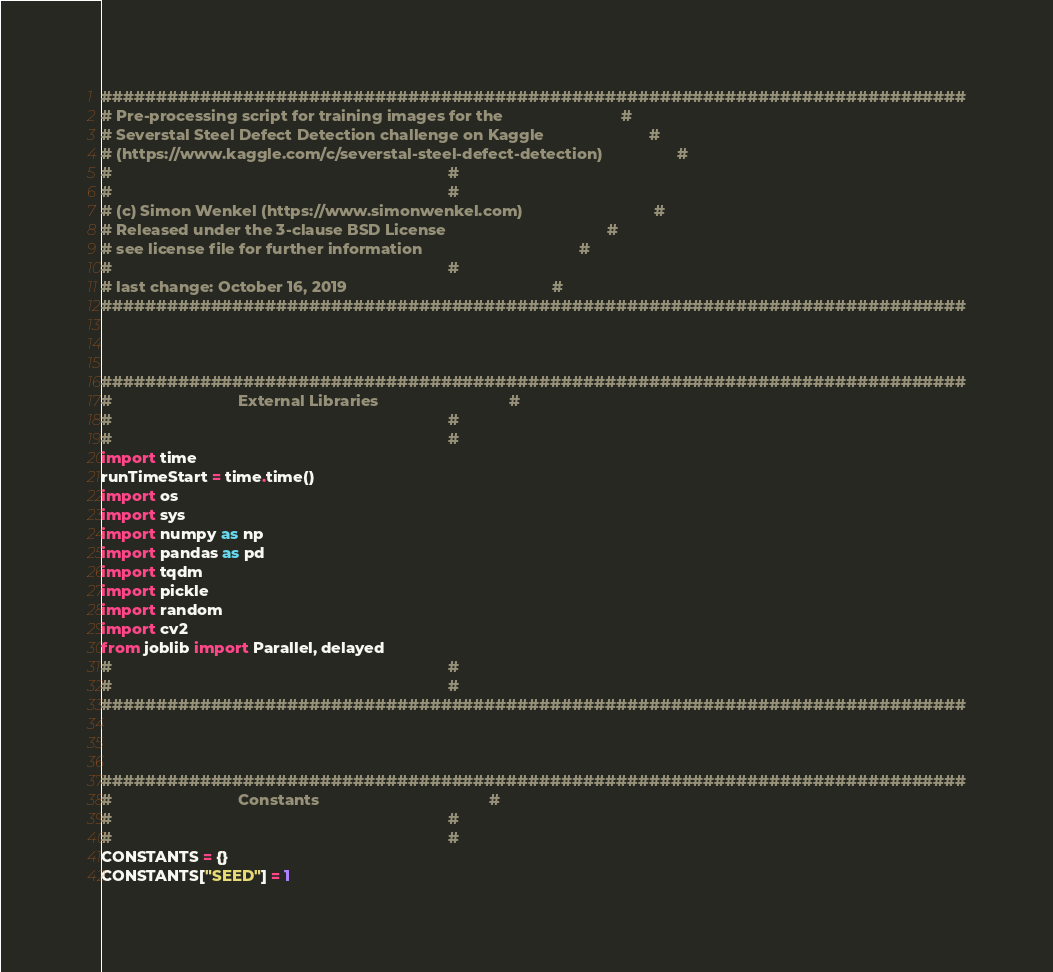Convert code to text. <code><loc_0><loc_0><loc_500><loc_500><_Python_>###############################################################################
# Pre-processing script for training images for the                           #
# Severstal Steel Defect Detection challenge on Kaggle                        #
# (https://www.kaggle.com/c/severstal-steel-defect-detection)                 #
#                                                                             #
#                                                                             #
# (c) Simon Wenkel (https://www.simonwenkel.com)                              #
# Released under the 3-clause BSD License                                     #
# see license file for further information                                    #
#                                                                             #
# last change: October 16, 2019                                               #
###############################################################################



###############################################################################
#                             External Libraries                              #
#                                                                             #
#                                                                             #
import time
runTimeStart = time.time()
import os
import sys
import numpy as np
import pandas as pd
import tqdm
import pickle
import random
import cv2
from joblib import Parallel, delayed
#                                                                             #
#                                                                             #
###############################################################################



###############################################################################
#                             Constants                                       #
#                                                                             #
#                                                                             #
CONSTANTS = {}
CONSTANTS["SEED"] = 1</code> 